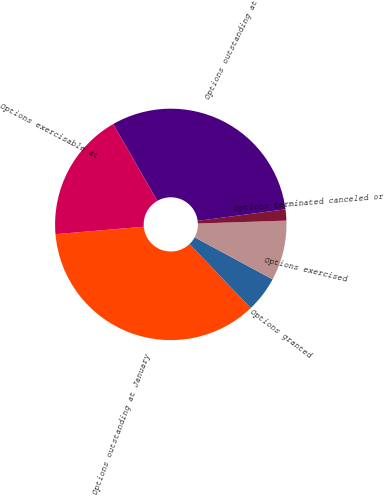<chart> <loc_0><loc_0><loc_500><loc_500><pie_chart><fcel>Options outstanding at January<fcel>Options granted<fcel>Options exercised<fcel>Options terminated canceled or<fcel>Options outstanding at<fcel>Options exercisable at<nl><fcel>35.8%<fcel>4.98%<fcel>8.4%<fcel>1.56%<fcel>31.21%<fcel>18.06%<nl></chart> 